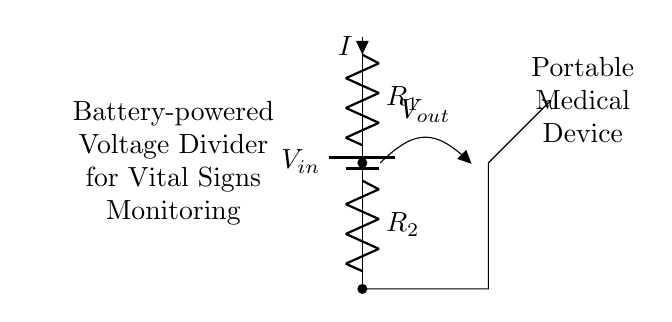What is the input voltage of the circuit? The input voltage, labeled as V_in in the circuit, is the voltage supplied by the battery. Since the exact value is not mentioned in the diagram, it is typically assumed to be the standard battery voltage used in portable medical devices, possibly 3V or 9V.
Answer: V_in What are the two resistances in the voltage divider? The resistances in the voltage divider circuit are labeled as R_1 and R_2. These resistors are crucial as they set the output voltage by dividing the input voltage based on their resistance values.
Answer: R_1 and R_2 What is the output voltage across R_2? The output voltage, labeled as V_out in the circuit, can be quantified using the voltage divider formula: V_out = V_in * (R_2 / (R_1 + R_2)). Without specific values for R_1 and R_2, the exact numerical value cannot be determined, but it represents the voltage across R_2.
Answer: V_out How does current flow through the circuit? Current, denoted as I in the circuit, flows from the higher potential side of the battery (V_in) through R_1 and R_2, returning to the lower potential side of the battery. The flow direction is indicated by the arrow pointing away from R_1, denoting conventional current flow.
Answer: From V_in through R_1 to R_2 What is the purpose of this voltage divider in the medical device? The voltage divider is designed to provide a specific output voltage, V_out, that is lower than the input voltage, which can be safely used to monitor vital signs without damaging the sensor circuitry. This is essential for ensuring the proper functioning of sensitive electronic components in the device.
Answer: To provide a safe output voltage What happens if R_1 is much larger than R_2? If R_1 is significantly larger than R_2, most of the input voltage will drop across R_1, resulting in a much smaller output voltage at R_2. This means that the device may not have sufficient voltage to operate properly, which can affect the readings of vital signs monitored by the device.
Answer: Output voltage decreases 